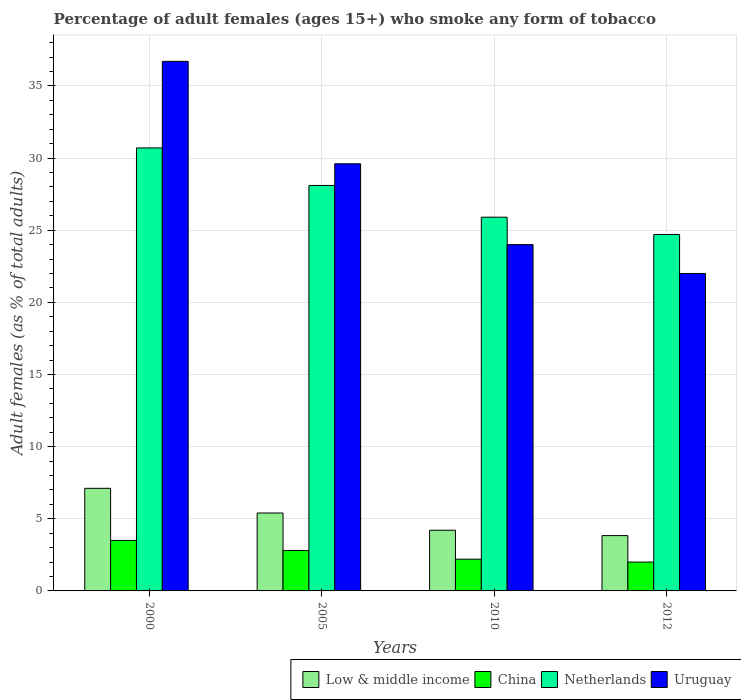What is the label of the 1st group of bars from the left?
Your answer should be very brief. 2000. What is the percentage of adult females who smoke in Netherlands in 2005?
Your answer should be very brief. 28.1. Across all years, what is the maximum percentage of adult females who smoke in Uruguay?
Keep it short and to the point. 36.7. Across all years, what is the minimum percentage of adult females who smoke in Netherlands?
Your answer should be compact. 24.7. In which year was the percentage of adult females who smoke in China maximum?
Your answer should be compact. 2000. In which year was the percentage of adult females who smoke in Netherlands minimum?
Provide a succinct answer. 2012. What is the total percentage of adult females who smoke in Low & middle income in the graph?
Your answer should be compact. 20.55. What is the difference between the percentage of adult females who smoke in Uruguay in 2000 and that in 2005?
Provide a short and direct response. 7.1. What is the difference between the percentage of adult females who smoke in Uruguay in 2010 and the percentage of adult females who smoke in China in 2012?
Ensure brevity in your answer.  22. What is the average percentage of adult females who smoke in China per year?
Provide a succinct answer. 2.62. In the year 2010, what is the difference between the percentage of adult females who smoke in China and percentage of adult females who smoke in Netherlands?
Your answer should be compact. -23.7. In how many years, is the percentage of adult females who smoke in Low & middle income greater than 18 %?
Offer a terse response. 0. What is the ratio of the percentage of adult females who smoke in Netherlands in 2005 to that in 2012?
Offer a terse response. 1.14. Is the percentage of adult females who smoke in Low & middle income in 2000 less than that in 2005?
Ensure brevity in your answer.  No. Is the difference between the percentage of adult females who smoke in China in 2000 and 2010 greater than the difference between the percentage of adult females who smoke in Netherlands in 2000 and 2010?
Provide a short and direct response. No. What is the difference between the highest and the second highest percentage of adult females who smoke in China?
Provide a succinct answer. 0.7. What is the difference between the highest and the lowest percentage of adult females who smoke in Uruguay?
Provide a short and direct response. 14.7. In how many years, is the percentage of adult females who smoke in China greater than the average percentage of adult females who smoke in China taken over all years?
Give a very brief answer. 2. Is the sum of the percentage of adult females who smoke in Low & middle income in 2005 and 2012 greater than the maximum percentage of adult females who smoke in Netherlands across all years?
Provide a succinct answer. No. What does the 4th bar from the left in 2005 represents?
Give a very brief answer. Uruguay. What does the 1st bar from the right in 2000 represents?
Your response must be concise. Uruguay. Are all the bars in the graph horizontal?
Your answer should be compact. No. How many years are there in the graph?
Offer a terse response. 4. What is the difference between two consecutive major ticks on the Y-axis?
Make the answer very short. 5. Are the values on the major ticks of Y-axis written in scientific E-notation?
Keep it short and to the point. No. Does the graph contain any zero values?
Make the answer very short. No. How are the legend labels stacked?
Provide a short and direct response. Horizontal. What is the title of the graph?
Offer a very short reply. Percentage of adult females (ages 15+) who smoke any form of tobacco. Does "Egypt, Arab Rep." appear as one of the legend labels in the graph?
Your response must be concise. No. What is the label or title of the X-axis?
Provide a succinct answer. Years. What is the label or title of the Y-axis?
Offer a terse response. Adult females (as % of total adults). What is the Adult females (as % of total adults) of Low & middle income in 2000?
Provide a short and direct response. 7.11. What is the Adult females (as % of total adults) of Netherlands in 2000?
Provide a succinct answer. 30.7. What is the Adult females (as % of total adults) of Uruguay in 2000?
Your answer should be very brief. 36.7. What is the Adult females (as % of total adults) of Low & middle income in 2005?
Give a very brief answer. 5.4. What is the Adult females (as % of total adults) in Netherlands in 2005?
Offer a very short reply. 28.1. What is the Adult females (as % of total adults) of Uruguay in 2005?
Offer a terse response. 29.6. What is the Adult females (as % of total adults) of Low & middle income in 2010?
Your answer should be very brief. 4.21. What is the Adult females (as % of total adults) in Netherlands in 2010?
Provide a succinct answer. 25.9. What is the Adult females (as % of total adults) of Uruguay in 2010?
Your response must be concise. 24. What is the Adult females (as % of total adults) of Low & middle income in 2012?
Your answer should be very brief. 3.83. What is the Adult females (as % of total adults) in Netherlands in 2012?
Ensure brevity in your answer.  24.7. What is the Adult females (as % of total adults) in Uruguay in 2012?
Provide a short and direct response. 22. Across all years, what is the maximum Adult females (as % of total adults) in Low & middle income?
Provide a short and direct response. 7.11. Across all years, what is the maximum Adult females (as % of total adults) in China?
Offer a terse response. 3.5. Across all years, what is the maximum Adult females (as % of total adults) of Netherlands?
Offer a terse response. 30.7. Across all years, what is the maximum Adult females (as % of total adults) of Uruguay?
Provide a short and direct response. 36.7. Across all years, what is the minimum Adult females (as % of total adults) of Low & middle income?
Provide a succinct answer. 3.83. Across all years, what is the minimum Adult females (as % of total adults) in Netherlands?
Your response must be concise. 24.7. What is the total Adult females (as % of total adults) of Low & middle income in the graph?
Offer a terse response. 20.55. What is the total Adult females (as % of total adults) of Netherlands in the graph?
Give a very brief answer. 109.4. What is the total Adult females (as % of total adults) in Uruguay in the graph?
Your answer should be compact. 112.3. What is the difference between the Adult females (as % of total adults) of Low & middle income in 2000 and that in 2005?
Ensure brevity in your answer.  1.71. What is the difference between the Adult females (as % of total adults) in China in 2000 and that in 2005?
Ensure brevity in your answer.  0.7. What is the difference between the Adult females (as % of total adults) in Netherlands in 2000 and that in 2005?
Ensure brevity in your answer.  2.6. What is the difference between the Adult females (as % of total adults) in Low & middle income in 2000 and that in 2010?
Your answer should be compact. 2.9. What is the difference between the Adult females (as % of total adults) of China in 2000 and that in 2010?
Ensure brevity in your answer.  1.3. What is the difference between the Adult females (as % of total adults) of Netherlands in 2000 and that in 2010?
Your response must be concise. 4.8. What is the difference between the Adult females (as % of total adults) of Uruguay in 2000 and that in 2010?
Provide a succinct answer. 12.7. What is the difference between the Adult females (as % of total adults) of Low & middle income in 2000 and that in 2012?
Make the answer very short. 3.28. What is the difference between the Adult females (as % of total adults) of China in 2000 and that in 2012?
Provide a succinct answer. 1.5. What is the difference between the Adult females (as % of total adults) in Netherlands in 2000 and that in 2012?
Your response must be concise. 6. What is the difference between the Adult females (as % of total adults) in Low & middle income in 2005 and that in 2010?
Provide a short and direct response. 1.19. What is the difference between the Adult females (as % of total adults) in China in 2005 and that in 2010?
Keep it short and to the point. 0.6. What is the difference between the Adult females (as % of total adults) of Netherlands in 2005 and that in 2010?
Your answer should be compact. 2.2. What is the difference between the Adult females (as % of total adults) in Uruguay in 2005 and that in 2010?
Your answer should be very brief. 5.6. What is the difference between the Adult females (as % of total adults) of Low & middle income in 2005 and that in 2012?
Keep it short and to the point. 1.57. What is the difference between the Adult females (as % of total adults) of Netherlands in 2005 and that in 2012?
Make the answer very short. 3.4. What is the difference between the Adult females (as % of total adults) in Low & middle income in 2010 and that in 2012?
Offer a terse response. 0.37. What is the difference between the Adult females (as % of total adults) in China in 2010 and that in 2012?
Keep it short and to the point. 0.2. What is the difference between the Adult females (as % of total adults) of Low & middle income in 2000 and the Adult females (as % of total adults) of China in 2005?
Your answer should be compact. 4.31. What is the difference between the Adult females (as % of total adults) in Low & middle income in 2000 and the Adult females (as % of total adults) in Netherlands in 2005?
Make the answer very short. -20.99. What is the difference between the Adult females (as % of total adults) in Low & middle income in 2000 and the Adult females (as % of total adults) in Uruguay in 2005?
Offer a terse response. -22.49. What is the difference between the Adult females (as % of total adults) of China in 2000 and the Adult females (as % of total adults) of Netherlands in 2005?
Give a very brief answer. -24.6. What is the difference between the Adult females (as % of total adults) in China in 2000 and the Adult females (as % of total adults) in Uruguay in 2005?
Give a very brief answer. -26.1. What is the difference between the Adult females (as % of total adults) in Low & middle income in 2000 and the Adult females (as % of total adults) in China in 2010?
Offer a very short reply. 4.91. What is the difference between the Adult females (as % of total adults) in Low & middle income in 2000 and the Adult females (as % of total adults) in Netherlands in 2010?
Offer a terse response. -18.79. What is the difference between the Adult females (as % of total adults) of Low & middle income in 2000 and the Adult females (as % of total adults) of Uruguay in 2010?
Your answer should be compact. -16.89. What is the difference between the Adult females (as % of total adults) in China in 2000 and the Adult females (as % of total adults) in Netherlands in 2010?
Ensure brevity in your answer.  -22.4. What is the difference between the Adult females (as % of total adults) of China in 2000 and the Adult females (as % of total adults) of Uruguay in 2010?
Your answer should be very brief. -20.5. What is the difference between the Adult females (as % of total adults) of Netherlands in 2000 and the Adult females (as % of total adults) of Uruguay in 2010?
Your answer should be very brief. 6.7. What is the difference between the Adult females (as % of total adults) in Low & middle income in 2000 and the Adult females (as % of total adults) in China in 2012?
Offer a terse response. 5.11. What is the difference between the Adult females (as % of total adults) in Low & middle income in 2000 and the Adult females (as % of total adults) in Netherlands in 2012?
Your answer should be compact. -17.59. What is the difference between the Adult females (as % of total adults) of Low & middle income in 2000 and the Adult females (as % of total adults) of Uruguay in 2012?
Your response must be concise. -14.89. What is the difference between the Adult females (as % of total adults) in China in 2000 and the Adult females (as % of total adults) in Netherlands in 2012?
Provide a succinct answer. -21.2. What is the difference between the Adult females (as % of total adults) in China in 2000 and the Adult females (as % of total adults) in Uruguay in 2012?
Offer a very short reply. -18.5. What is the difference between the Adult females (as % of total adults) in Netherlands in 2000 and the Adult females (as % of total adults) in Uruguay in 2012?
Offer a terse response. 8.7. What is the difference between the Adult females (as % of total adults) of Low & middle income in 2005 and the Adult females (as % of total adults) of China in 2010?
Ensure brevity in your answer.  3.2. What is the difference between the Adult females (as % of total adults) in Low & middle income in 2005 and the Adult females (as % of total adults) in Netherlands in 2010?
Your response must be concise. -20.5. What is the difference between the Adult females (as % of total adults) in Low & middle income in 2005 and the Adult females (as % of total adults) in Uruguay in 2010?
Give a very brief answer. -18.6. What is the difference between the Adult females (as % of total adults) in China in 2005 and the Adult females (as % of total adults) in Netherlands in 2010?
Your response must be concise. -23.1. What is the difference between the Adult females (as % of total adults) in China in 2005 and the Adult females (as % of total adults) in Uruguay in 2010?
Offer a very short reply. -21.2. What is the difference between the Adult females (as % of total adults) in Low & middle income in 2005 and the Adult females (as % of total adults) in China in 2012?
Ensure brevity in your answer.  3.4. What is the difference between the Adult females (as % of total adults) of Low & middle income in 2005 and the Adult females (as % of total adults) of Netherlands in 2012?
Your answer should be very brief. -19.3. What is the difference between the Adult females (as % of total adults) of Low & middle income in 2005 and the Adult females (as % of total adults) of Uruguay in 2012?
Ensure brevity in your answer.  -16.6. What is the difference between the Adult females (as % of total adults) in China in 2005 and the Adult females (as % of total adults) in Netherlands in 2012?
Your response must be concise. -21.9. What is the difference between the Adult females (as % of total adults) in China in 2005 and the Adult females (as % of total adults) in Uruguay in 2012?
Ensure brevity in your answer.  -19.2. What is the difference between the Adult females (as % of total adults) of Netherlands in 2005 and the Adult females (as % of total adults) of Uruguay in 2012?
Ensure brevity in your answer.  6.1. What is the difference between the Adult females (as % of total adults) of Low & middle income in 2010 and the Adult females (as % of total adults) of China in 2012?
Offer a terse response. 2.21. What is the difference between the Adult females (as % of total adults) of Low & middle income in 2010 and the Adult females (as % of total adults) of Netherlands in 2012?
Your answer should be compact. -20.49. What is the difference between the Adult females (as % of total adults) of Low & middle income in 2010 and the Adult females (as % of total adults) of Uruguay in 2012?
Offer a terse response. -17.79. What is the difference between the Adult females (as % of total adults) of China in 2010 and the Adult females (as % of total adults) of Netherlands in 2012?
Provide a short and direct response. -22.5. What is the difference between the Adult females (as % of total adults) of China in 2010 and the Adult females (as % of total adults) of Uruguay in 2012?
Give a very brief answer. -19.8. What is the difference between the Adult females (as % of total adults) of Netherlands in 2010 and the Adult females (as % of total adults) of Uruguay in 2012?
Provide a succinct answer. 3.9. What is the average Adult females (as % of total adults) of Low & middle income per year?
Provide a short and direct response. 5.14. What is the average Adult females (as % of total adults) in China per year?
Make the answer very short. 2.62. What is the average Adult females (as % of total adults) of Netherlands per year?
Offer a terse response. 27.35. What is the average Adult females (as % of total adults) of Uruguay per year?
Provide a short and direct response. 28.07. In the year 2000, what is the difference between the Adult females (as % of total adults) of Low & middle income and Adult females (as % of total adults) of China?
Give a very brief answer. 3.61. In the year 2000, what is the difference between the Adult females (as % of total adults) in Low & middle income and Adult females (as % of total adults) in Netherlands?
Make the answer very short. -23.59. In the year 2000, what is the difference between the Adult females (as % of total adults) of Low & middle income and Adult females (as % of total adults) of Uruguay?
Keep it short and to the point. -29.59. In the year 2000, what is the difference between the Adult females (as % of total adults) in China and Adult females (as % of total adults) in Netherlands?
Give a very brief answer. -27.2. In the year 2000, what is the difference between the Adult females (as % of total adults) in China and Adult females (as % of total adults) in Uruguay?
Ensure brevity in your answer.  -33.2. In the year 2000, what is the difference between the Adult females (as % of total adults) in Netherlands and Adult females (as % of total adults) in Uruguay?
Offer a terse response. -6. In the year 2005, what is the difference between the Adult females (as % of total adults) in Low & middle income and Adult females (as % of total adults) in China?
Give a very brief answer. 2.6. In the year 2005, what is the difference between the Adult females (as % of total adults) of Low & middle income and Adult females (as % of total adults) of Netherlands?
Provide a succinct answer. -22.7. In the year 2005, what is the difference between the Adult females (as % of total adults) in Low & middle income and Adult females (as % of total adults) in Uruguay?
Give a very brief answer. -24.2. In the year 2005, what is the difference between the Adult females (as % of total adults) of China and Adult females (as % of total adults) of Netherlands?
Offer a terse response. -25.3. In the year 2005, what is the difference between the Adult females (as % of total adults) of China and Adult females (as % of total adults) of Uruguay?
Keep it short and to the point. -26.8. In the year 2005, what is the difference between the Adult females (as % of total adults) of Netherlands and Adult females (as % of total adults) of Uruguay?
Give a very brief answer. -1.5. In the year 2010, what is the difference between the Adult females (as % of total adults) of Low & middle income and Adult females (as % of total adults) of China?
Provide a short and direct response. 2.01. In the year 2010, what is the difference between the Adult females (as % of total adults) of Low & middle income and Adult females (as % of total adults) of Netherlands?
Make the answer very short. -21.69. In the year 2010, what is the difference between the Adult females (as % of total adults) of Low & middle income and Adult females (as % of total adults) of Uruguay?
Give a very brief answer. -19.79. In the year 2010, what is the difference between the Adult females (as % of total adults) in China and Adult females (as % of total adults) in Netherlands?
Ensure brevity in your answer.  -23.7. In the year 2010, what is the difference between the Adult females (as % of total adults) in China and Adult females (as % of total adults) in Uruguay?
Offer a very short reply. -21.8. In the year 2012, what is the difference between the Adult females (as % of total adults) of Low & middle income and Adult females (as % of total adults) of China?
Provide a short and direct response. 1.83. In the year 2012, what is the difference between the Adult females (as % of total adults) in Low & middle income and Adult females (as % of total adults) in Netherlands?
Provide a short and direct response. -20.87. In the year 2012, what is the difference between the Adult females (as % of total adults) in Low & middle income and Adult females (as % of total adults) in Uruguay?
Your answer should be very brief. -18.17. In the year 2012, what is the difference between the Adult females (as % of total adults) of China and Adult females (as % of total adults) of Netherlands?
Your answer should be very brief. -22.7. In the year 2012, what is the difference between the Adult females (as % of total adults) in China and Adult females (as % of total adults) in Uruguay?
Provide a succinct answer. -20. What is the ratio of the Adult females (as % of total adults) in Low & middle income in 2000 to that in 2005?
Your response must be concise. 1.32. What is the ratio of the Adult females (as % of total adults) of China in 2000 to that in 2005?
Make the answer very short. 1.25. What is the ratio of the Adult females (as % of total adults) of Netherlands in 2000 to that in 2005?
Make the answer very short. 1.09. What is the ratio of the Adult females (as % of total adults) in Uruguay in 2000 to that in 2005?
Provide a succinct answer. 1.24. What is the ratio of the Adult females (as % of total adults) of Low & middle income in 2000 to that in 2010?
Your answer should be very brief. 1.69. What is the ratio of the Adult females (as % of total adults) in China in 2000 to that in 2010?
Offer a terse response. 1.59. What is the ratio of the Adult females (as % of total adults) in Netherlands in 2000 to that in 2010?
Provide a short and direct response. 1.19. What is the ratio of the Adult females (as % of total adults) in Uruguay in 2000 to that in 2010?
Provide a succinct answer. 1.53. What is the ratio of the Adult females (as % of total adults) of Low & middle income in 2000 to that in 2012?
Offer a terse response. 1.85. What is the ratio of the Adult females (as % of total adults) in China in 2000 to that in 2012?
Your response must be concise. 1.75. What is the ratio of the Adult females (as % of total adults) of Netherlands in 2000 to that in 2012?
Provide a succinct answer. 1.24. What is the ratio of the Adult females (as % of total adults) of Uruguay in 2000 to that in 2012?
Your response must be concise. 1.67. What is the ratio of the Adult females (as % of total adults) in Low & middle income in 2005 to that in 2010?
Provide a succinct answer. 1.28. What is the ratio of the Adult females (as % of total adults) in China in 2005 to that in 2010?
Your answer should be compact. 1.27. What is the ratio of the Adult females (as % of total adults) in Netherlands in 2005 to that in 2010?
Offer a terse response. 1.08. What is the ratio of the Adult females (as % of total adults) in Uruguay in 2005 to that in 2010?
Your answer should be very brief. 1.23. What is the ratio of the Adult females (as % of total adults) in Low & middle income in 2005 to that in 2012?
Make the answer very short. 1.41. What is the ratio of the Adult females (as % of total adults) of Netherlands in 2005 to that in 2012?
Ensure brevity in your answer.  1.14. What is the ratio of the Adult females (as % of total adults) of Uruguay in 2005 to that in 2012?
Your answer should be very brief. 1.35. What is the ratio of the Adult females (as % of total adults) of Low & middle income in 2010 to that in 2012?
Offer a terse response. 1.1. What is the ratio of the Adult females (as % of total adults) in Netherlands in 2010 to that in 2012?
Your answer should be very brief. 1.05. What is the ratio of the Adult females (as % of total adults) of Uruguay in 2010 to that in 2012?
Offer a terse response. 1.09. What is the difference between the highest and the second highest Adult females (as % of total adults) in Low & middle income?
Make the answer very short. 1.71. What is the difference between the highest and the second highest Adult females (as % of total adults) of China?
Your answer should be very brief. 0.7. What is the difference between the highest and the second highest Adult females (as % of total adults) in Uruguay?
Keep it short and to the point. 7.1. What is the difference between the highest and the lowest Adult females (as % of total adults) of Low & middle income?
Offer a very short reply. 3.28. What is the difference between the highest and the lowest Adult females (as % of total adults) of China?
Provide a succinct answer. 1.5. What is the difference between the highest and the lowest Adult females (as % of total adults) of Netherlands?
Your answer should be very brief. 6. 